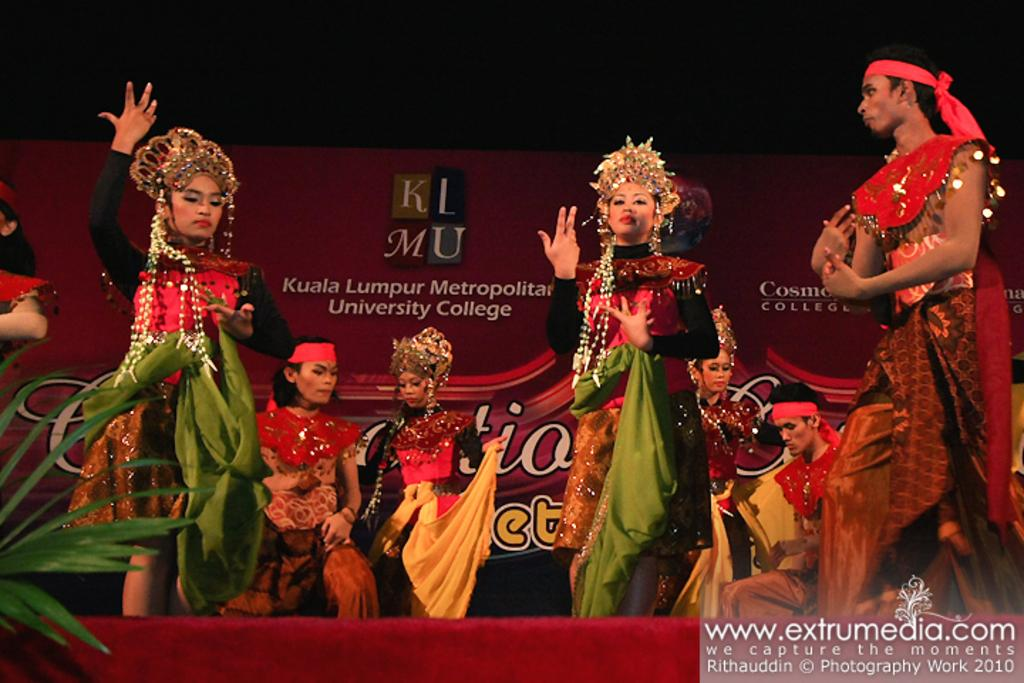What is the main feature of the image? There is a stage in the image. What are the people on the stage doing? The people are dancing on the stage. How are the dancers dressed? The people are wearing different kinds of costumes. What type of organization is responsible for the coil of rope on the stage? There is no coil of rope or any reference to an organization in the image. 